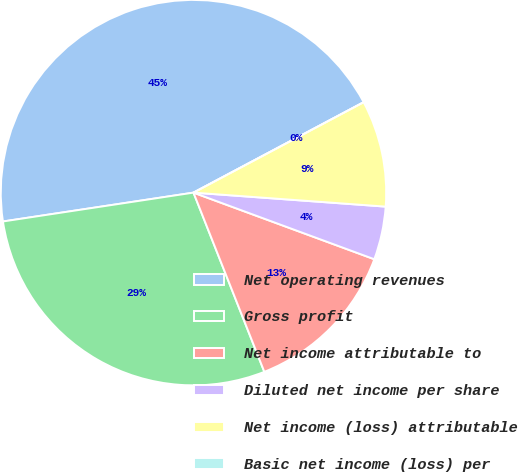Convert chart to OTSL. <chart><loc_0><loc_0><loc_500><loc_500><pie_chart><fcel>Net operating revenues<fcel>Gross profit<fcel>Net income attributable to<fcel>Diluted net income per share<fcel>Net income (loss) attributable<fcel>Basic net income (loss) per<nl><fcel>44.62%<fcel>28.6%<fcel>13.39%<fcel>4.46%<fcel>8.93%<fcel>0.0%<nl></chart> 